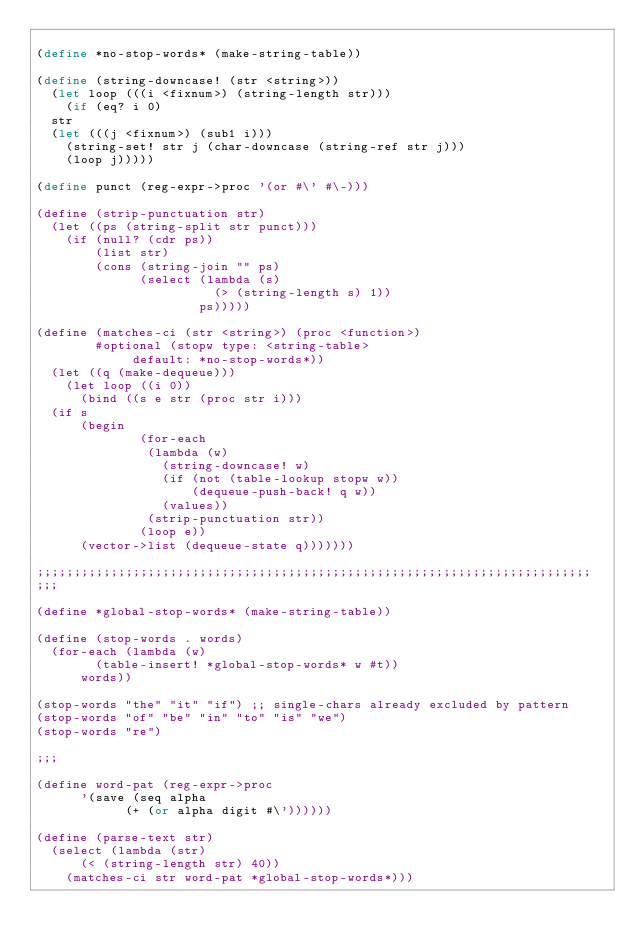Convert code to text. <code><loc_0><loc_0><loc_500><loc_500><_Scheme_>
(define *no-stop-words* (make-string-table))

(define (string-downcase! (str <string>))
  (let loop (((i <fixnum>) (string-length str)))
    (if (eq? i 0)
	str
	(let (((j <fixnum>) (sub1 i)))
	  (string-set! str j (char-downcase (string-ref str j)))
	  (loop j)))))

(define punct (reg-expr->proc '(or #\' #\-)))

(define (strip-punctuation str)
  (let ((ps (string-split str punct)))
    (if (null? (cdr ps))
        (list str)
        (cons (string-join "" ps) 
              (select (lambda (s)
                        (> (string-length s) 1))
                      ps)))))

(define (matches-ci (str <string>) (proc <function>) 
		    #optional (stopw type: <string-table> 
				     default: *no-stop-words*))
  (let ((q (make-dequeue)))
    (let loop ((i 0))
      (bind ((s e str (proc str i)))
	(if s
	    (begin
              (for-each
               (lambda (w)
                 (string-downcase! w)
                 (if (not (table-lookup stopw w))
                     (dequeue-push-back! q w))
                 (values))
               (strip-punctuation str))
              (loop e))
	    (vector->list (dequeue-state q)))))))

;;;;;;;;;;;;;;;;;;;;;;;;;;;;;;;;;;;;;;;;;;;;;;;;;;;;;;;;;;;;;;;;;;;;;;;;;;;
;;;

(define *global-stop-words* (make-string-table))

(define (stop-words . words)
  (for-each (lambda (w)
	      (table-insert! *global-stop-words* w #t))
	    words))

(stop-words "the" "it" "if") ;; single-chars already excluded by pattern
(stop-words "of" "be" "in" "to" "is" "we")
(stop-words "re")

;;;

(define word-pat (reg-expr->proc 
		  '(save (seq alpha
			      (+ (or alpha digit #\'))))))

(define (parse-text str)
  (select (lambda (str)
	    (< (string-length str) 40))
	  (matches-ci str word-pat *global-stop-words*)))
</code> 